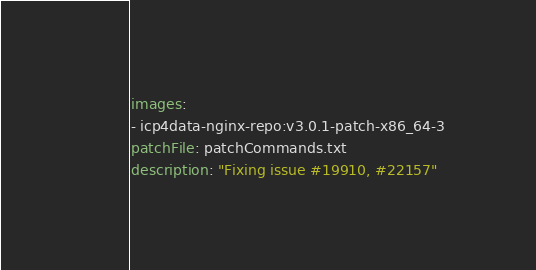Convert code to text. <code><loc_0><loc_0><loc_500><loc_500><_YAML_>images:
- icp4data-nginx-repo:v3.0.1-patch-x86_64-3
patchFile: patchCommands.txt
description: "Fixing issue #19910, #22157"</code> 